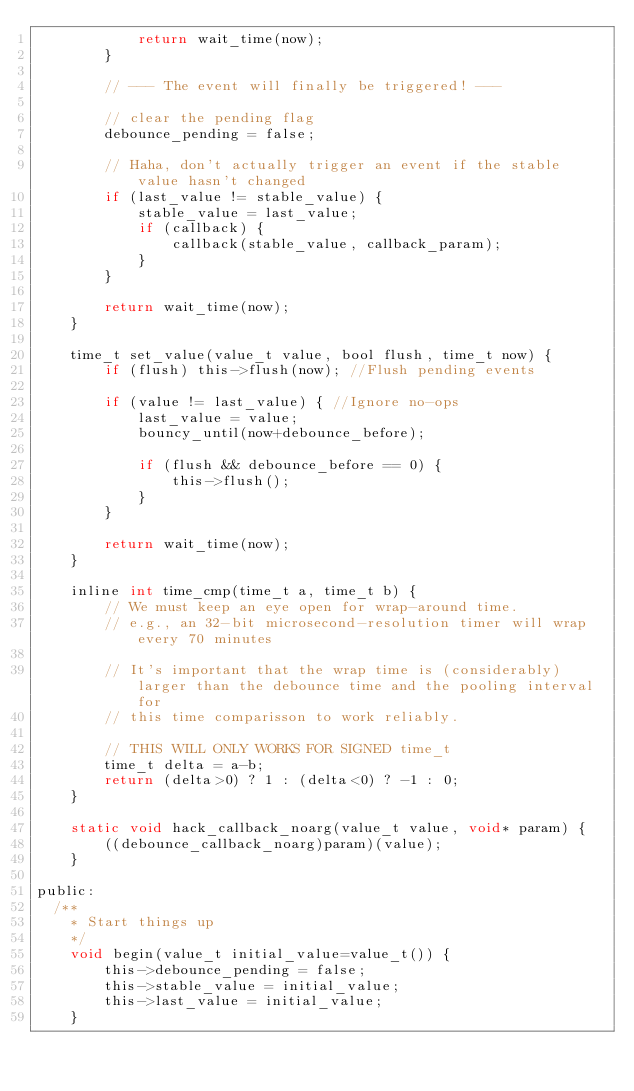Convert code to text. <code><loc_0><loc_0><loc_500><loc_500><_C_>            return wait_time(now);
        }

        // --- The event will finally be triggered! ---

        // clear the pending flag
        debounce_pending = false;

        // Haha, don't actually trigger an event if the stable value hasn't changed
        if (last_value != stable_value) {
            stable_value = last_value;
            if (callback) {
                callback(stable_value, callback_param);
            }
        }

        return wait_time(now);
    }

    time_t set_value(value_t value, bool flush, time_t now) {
        if (flush) this->flush(now); //Flush pending events

        if (value != last_value) { //Ignore no-ops
            last_value = value;
            bouncy_until(now+debounce_before);

            if (flush && debounce_before == 0) {
                this->flush();
            }
        }

        return wait_time(now);
    }

    inline int time_cmp(time_t a, time_t b) {
        // We must keep an eye open for wrap-around time.
        // e.g., an 32-bit microsecond-resolution timer will wrap every 70 minutes

        // It's important that the wrap time is (considerably) larger than the debounce time and the pooling interval for
        // this time comparisson to work reliably.

        // THIS WILL ONLY WORKS FOR SIGNED time_t
        time_t delta = a-b;
        return (delta>0) ? 1 : (delta<0) ? -1 : 0;
    }

    static void hack_callback_noarg(value_t value, void* param) {
        ((debounce_callback_noarg)param)(value);
    }

public:
  /**
    * Start things up
    */
    void begin(value_t initial_value=value_t()) {
        this->debounce_pending = false;
        this->stable_value = initial_value;
        this->last_value = initial_value;
    }

</code> 